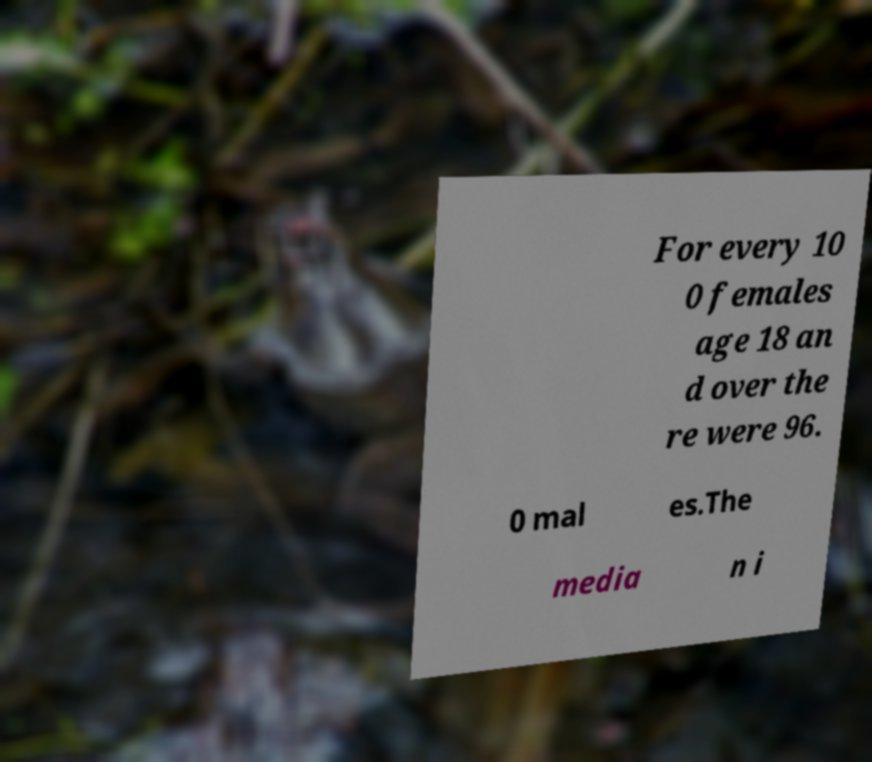Can you read and provide the text displayed in the image?This photo seems to have some interesting text. Can you extract and type it out for me? For every 10 0 females age 18 an d over the re were 96. 0 mal es.The media n i 